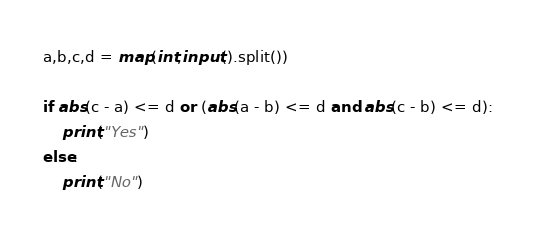Convert code to text. <code><loc_0><loc_0><loc_500><loc_500><_Python_>a,b,c,d = map(int,input().split())

if abs(c - a) <= d or (abs(a - b) <= d and abs(c - b) <= d):
    print("Yes")
else:
    print("No")
</code> 